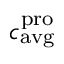Convert formula to latex. <formula><loc_0><loc_0><loc_500><loc_500>c _ { a v g } ^ { p r o }</formula> 